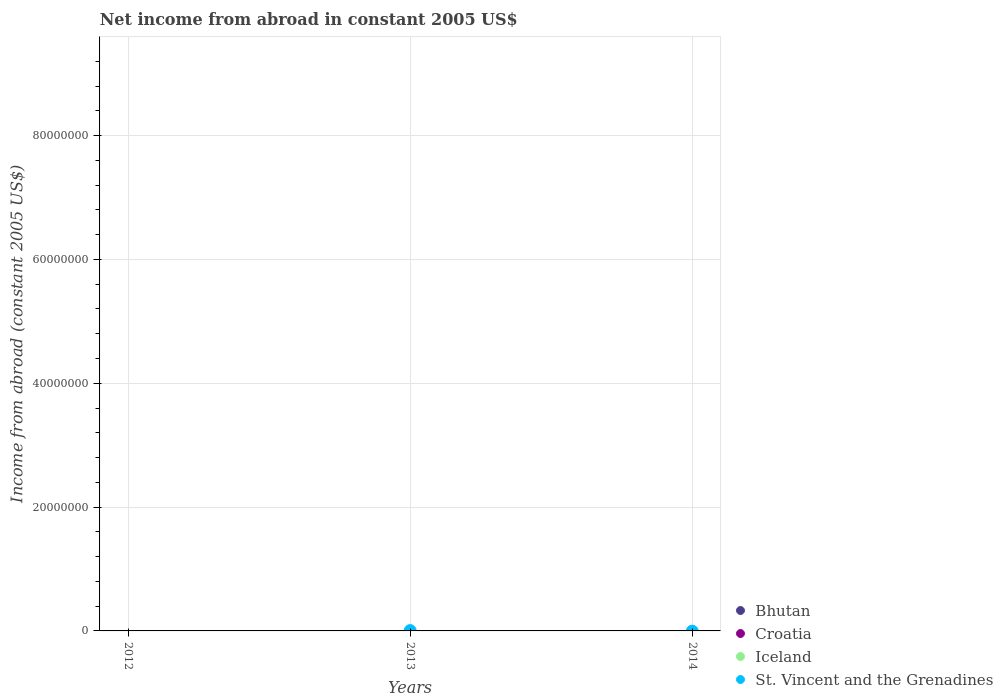Across all years, what is the maximum net income from abroad in St. Vincent and the Grenadines?
Provide a short and direct response. 5.08e+04. What is the total net income from abroad in St. Vincent and the Grenadines in the graph?
Make the answer very short. 5.08e+04. What is the difference between the net income from abroad in Bhutan in 2013 and the net income from abroad in St. Vincent and the Grenadines in 2012?
Keep it short and to the point. 0. In how many years, is the net income from abroad in St. Vincent and the Grenadines greater than 28000000 US$?
Your response must be concise. 0. What is the difference between the highest and the lowest net income from abroad in St. Vincent and the Grenadines?
Ensure brevity in your answer.  5.08e+04. In how many years, is the net income from abroad in St. Vincent and the Grenadines greater than the average net income from abroad in St. Vincent and the Grenadines taken over all years?
Offer a very short reply. 1. Does the net income from abroad in Bhutan monotonically increase over the years?
Offer a terse response. No. Is the net income from abroad in Iceland strictly greater than the net income from abroad in St. Vincent and the Grenadines over the years?
Ensure brevity in your answer.  No. How many years are there in the graph?
Provide a succinct answer. 3. Are the values on the major ticks of Y-axis written in scientific E-notation?
Your answer should be compact. No. Does the graph contain any zero values?
Offer a very short reply. Yes. Where does the legend appear in the graph?
Make the answer very short. Bottom right. How are the legend labels stacked?
Offer a very short reply. Vertical. What is the title of the graph?
Give a very brief answer. Net income from abroad in constant 2005 US$. What is the label or title of the X-axis?
Keep it short and to the point. Years. What is the label or title of the Y-axis?
Ensure brevity in your answer.  Income from abroad (constant 2005 US$). What is the Income from abroad (constant 2005 US$) in Iceland in 2012?
Offer a terse response. 0. What is the Income from abroad (constant 2005 US$) in St. Vincent and the Grenadines in 2012?
Ensure brevity in your answer.  0. What is the Income from abroad (constant 2005 US$) of Bhutan in 2013?
Offer a terse response. 0. What is the Income from abroad (constant 2005 US$) of Iceland in 2013?
Give a very brief answer. 0. What is the Income from abroad (constant 2005 US$) of St. Vincent and the Grenadines in 2013?
Your response must be concise. 5.08e+04. What is the Income from abroad (constant 2005 US$) of Bhutan in 2014?
Keep it short and to the point. 0. Across all years, what is the maximum Income from abroad (constant 2005 US$) in St. Vincent and the Grenadines?
Give a very brief answer. 5.08e+04. Across all years, what is the minimum Income from abroad (constant 2005 US$) in St. Vincent and the Grenadines?
Give a very brief answer. 0. What is the total Income from abroad (constant 2005 US$) in Bhutan in the graph?
Your response must be concise. 0. What is the total Income from abroad (constant 2005 US$) in Croatia in the graph?
Give a very brief answer. 0. What is the total Income from abroad (constant 2005 US$) in St. Vincent and the Grenadines in the graph?
Offer a very short reply. 5.08e+04. What is the average Income from abroad (constant 2005 US$) in St. Vincent and the Grenadines per year?
Provide a succinct answer. 1.69e+04. What is the difference between the highest and the lowest Income from abroad (constant 2005 US$) in St. Vincent and the Grenadines?
Give a very brief answer. 5.08e+04. 